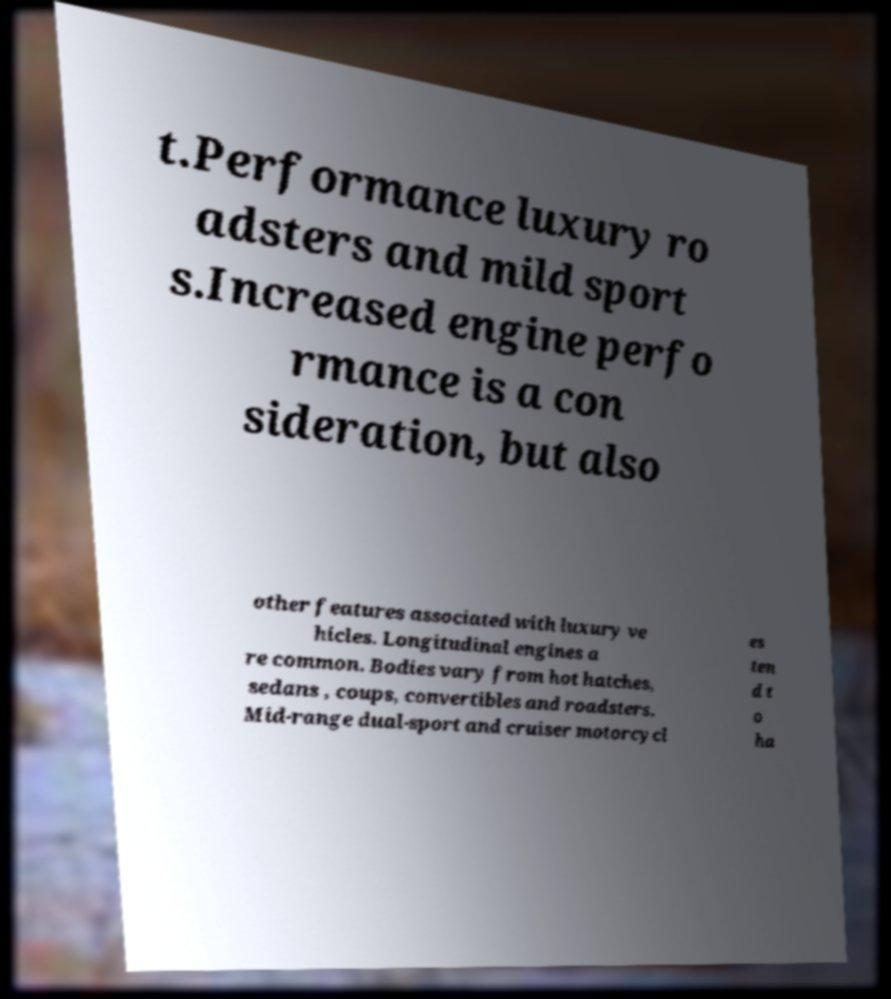Could you assist in decoding the text presented in this image and type it out clearly? t.Performance luxury ro adsters and mild sport s.Increased engine perfo rmance is a con sideration, but also other features associated with luxury ve hicles. Longitudinal engines a re common. Bodies vary from hot hatches, sedans , coups, convertibles and roadsters. Mid-range dual-sport and cruiser motorcycl es ten d t o ha 